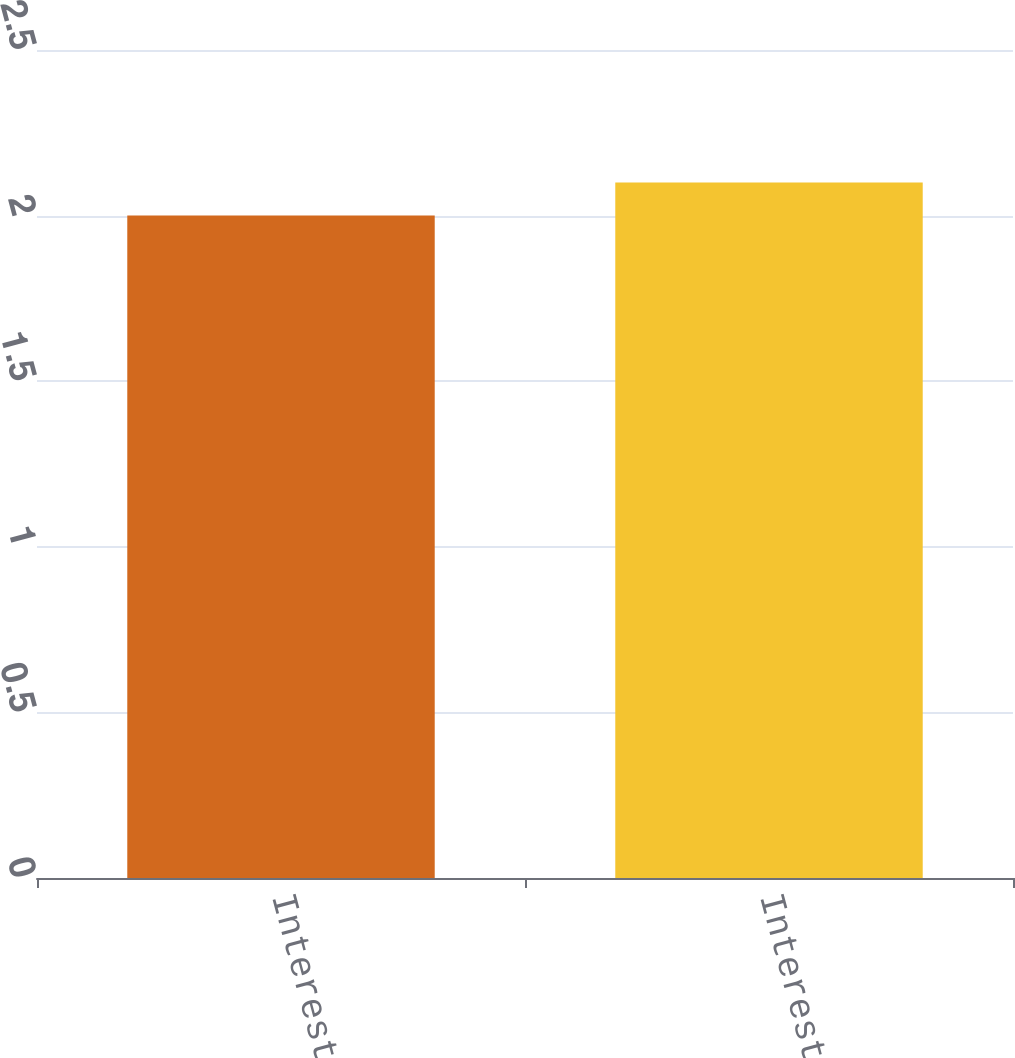Convert chart to OTSL. <chart><loc_0><loc_0><loc_500><loc_500><bar_chart><fcel>Interest expense<fcel>Interest expense net<nl><fcel>2<fcel>2.1<nl></chart> 